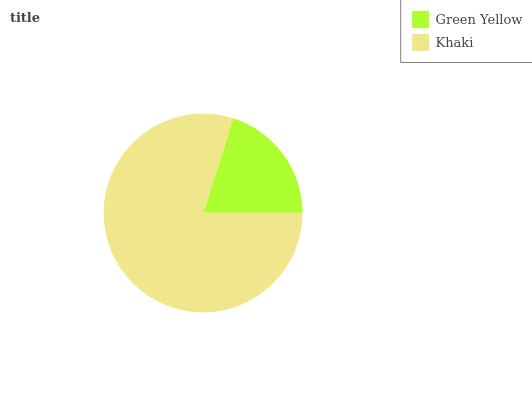Is Green Yellow the minimum?
Answer yes or no. Yes. Is Khaki the maximum?
Answer yes or no. Yes. Is Khaki the minimum?
Answer yes or no. No. Is Khaki greater than Green Yellow?
Answer yes or no. Yes. Is Green Yellow less than Khaki?
Answer yes or no. Yes. Is Green Yellow greater than Khaki?
Answer yes or no. No. Is Khaki less than Green Yellow?
Answer yes or no. No. Is Khaki the high median?
Answer yes or no. Yes. Is Green Yellow the low median?
Answer yes or no. Yes. Is Green Yellow the high median?
Answer yes or no. No. Is Khaki the low median?
Answer yes or no. No. 